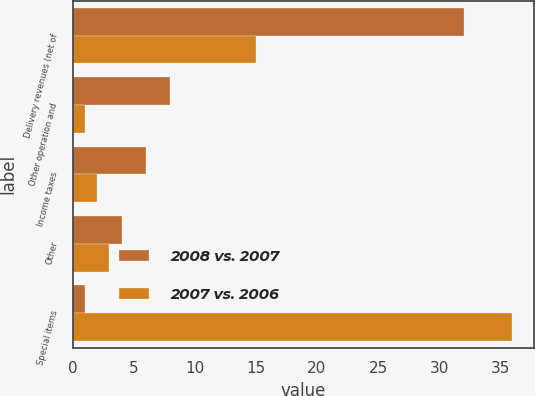Convert chart to OTSL. <chart><loc_0><loc_0><loc_500><loc_500><stacked_bar_chart><ecel><fcel>Delivery revenues (net of<fcel>Other operation and<fcel>Income taxes<fcel>Other<fcel>Special items<nl><fcel>2008 vs. 2007<fcel>32<fcel>8<fcel>6<fcel>4<fcel>1<nl><fcel>2007 vs. 2006<fcel>15<fcel>1<fcel>2<fcel>3<fcel>36<nl></chart> 